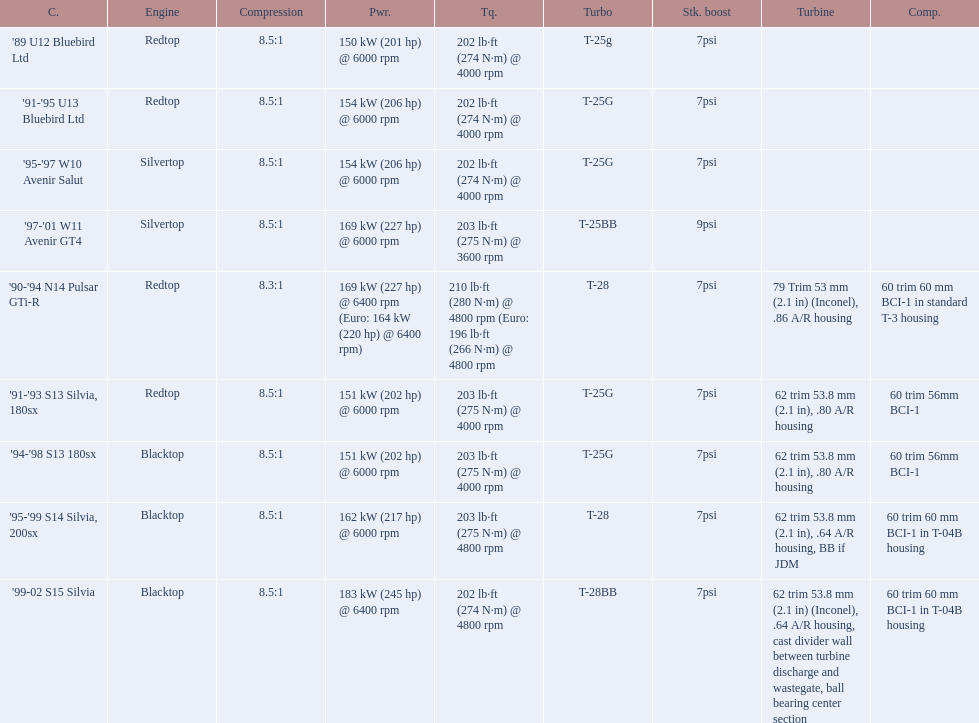What are all the cars? '89 U12 Bluebird Ltd, '91-'95 U13 Bluebird Ltd, '95-'97 W10 Avenir Salut, '97-'01 W11 Avenir GT4, '90-'94 N14 Pulsar GTi-R, '91-'93 S13 Silvia, 180sx, '94-'98 S13 180sx, '95-'99 S14 Silvia, 200sx, '99-02 S15 Silvia. What are their stock boosts? 7psi, 7psi, 7psi, 9psi, 7psi, 7psi, 7psi, 7psi, 7psi. And which car has the highest stock boost? '97-'01 W11 Avenir GT4. 